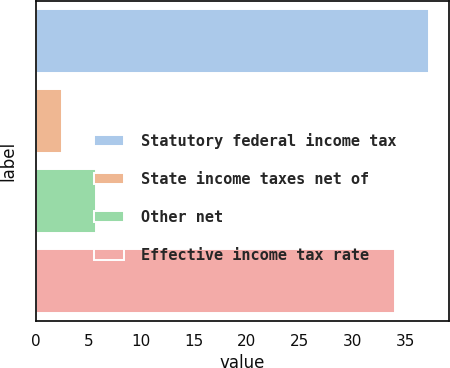Convert chart. <chart><loc_0><loc_0><loc_500><loc_500><bar_chart><fcel>Statutory federal income tax<fcel>State income taxes net of<fcel>Other net<fcel>Effective income tax rate<nl><fcel>37.25<fcel>2.5<fcel>5.75<fcel>34<nl></chart> 